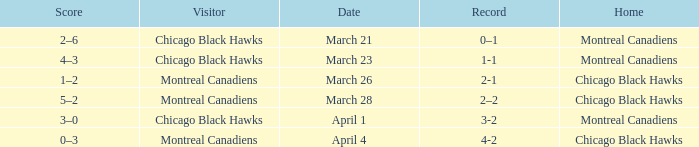Which home team has a record of 3-2? Montreal Canadiens. 